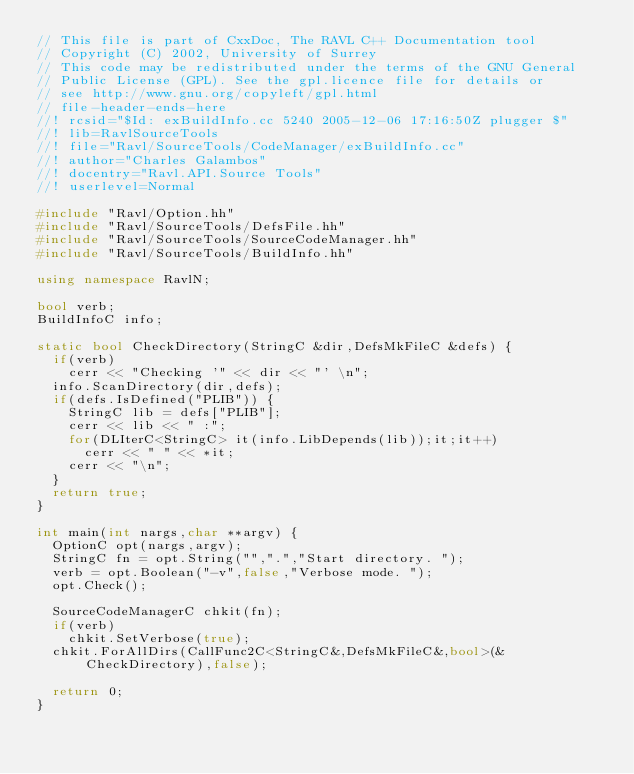Convert code to text. <code><loc_0><loc_0><loc_500><loc_500><_C++_>// This file is part of CxxDoc, The RAVL C++ Documentation tool 
// Copyright (C) 2002, University of Surrey
// This code may be redistributed under the terms of the GNU General 
// Public License (GPL). See the gpl.licence file for details or
// see http://www.gnu.org/copyleft/gpl.html
// file-header-ends-here
//! rcsid="$Id: exBuildInfo.cc 5240 2005-12-06 17:16:50Z plugger $"
//! lib=RavlSourceTools
//! file="Ravl/SourceTools/CodeManager/exBuildInfo.cc"
//! author="Charles Galambos"
//! docentry="Ravl.API.Source Tools"
//! userlevel=Normal

#include "Ravl/Option.hh"
#include "Ravl/SourceTools/DefsFile.hh"
#include "Ravl/SourceTools/SourceCodeManager.hh"
#include "Ravl/SourceTools/BuildInfo.hh"

using namespace RavlN;

bool verb;
BuildInfoC info;

static bool CheckDirectory(StringC &dir,DefsMkFileC &defs) {
  if(verb)
    cerr << "Checking '" << dir << "' \n";
  info.ScanDirectory(dir,defs);
  if(defs.IsDefined("PLIB")) {
    StringC lib = defs["PLIB"];
    cerr << lib << " :";
    for(DLIterC<StringC> it(info.LibDepends(lib));it;it++)
      cerr << " " << *it;
    cerr << "\n";
  }
  return true;
}

int main(int nargs,char **argv) {
  OptionC opt(nargs,argv);
  StringC fn = opt.String("",".","Start directory. ");
  verb = opt.Boolean("-v",false,"Verbose mode. ");
  opt.Check();
  
  SourceCodeManagerC chkit(fn);
  if(verb)
    chkit.SetVerbose(true);  
  chkit.ForAllDirs(CallFunc2C<StringC&,DefsMkFileC&,bool>(&CheckDirectory),false);

  return 0;
}
</code> 